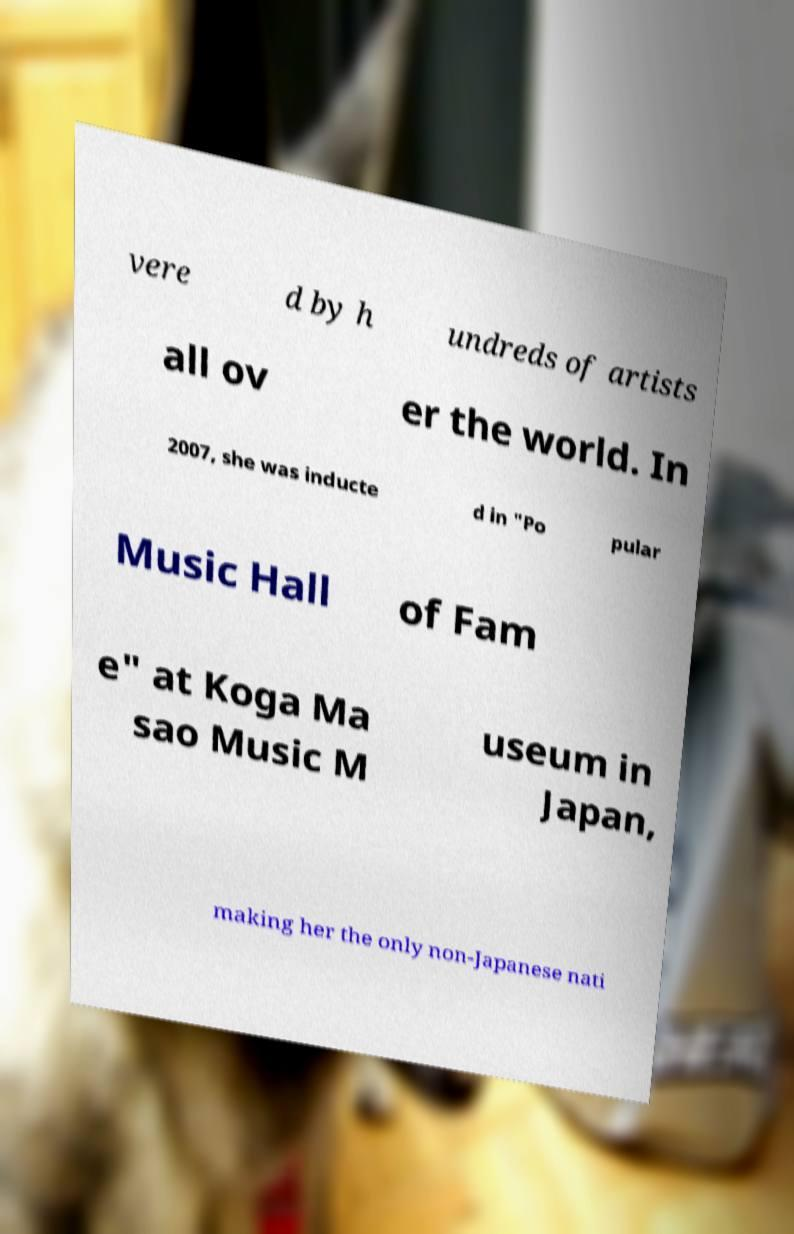Can you read and provide the text displayed in the image?This photo seems to have some interesting text. Can you extract and type it out for me? vere d by h undreds of artists all ov er the world. In 2007, she was inducte d in "Po pular Music Hall of Fam e" at Koga Ma sao Music M useum in Japan, making her the only non-Japanese nati 